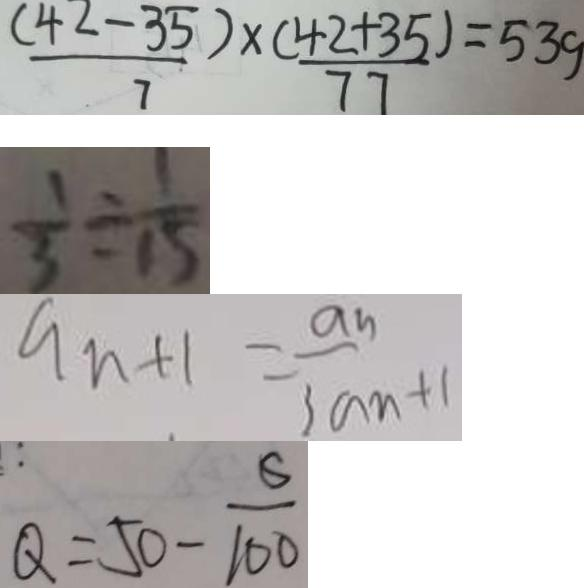<formula> <loc_0><loc_0><loc_500><loc_500>\frac { ( 4 2 - 3 5 ) } { 7 } \times \frac { ( 4 2 + 3 5 ) } { 7 7 } = 5 3 9 
 \frac { 1 } { 3 } \div \frac { 1 } { 1 5 } 
 a _ { n + 1 } = \frac { a _ { n } } { 3 a _ { n } + 1 } 
 Q = 5 0 - \frac { 6 } { 1 0 0 }</formula> 